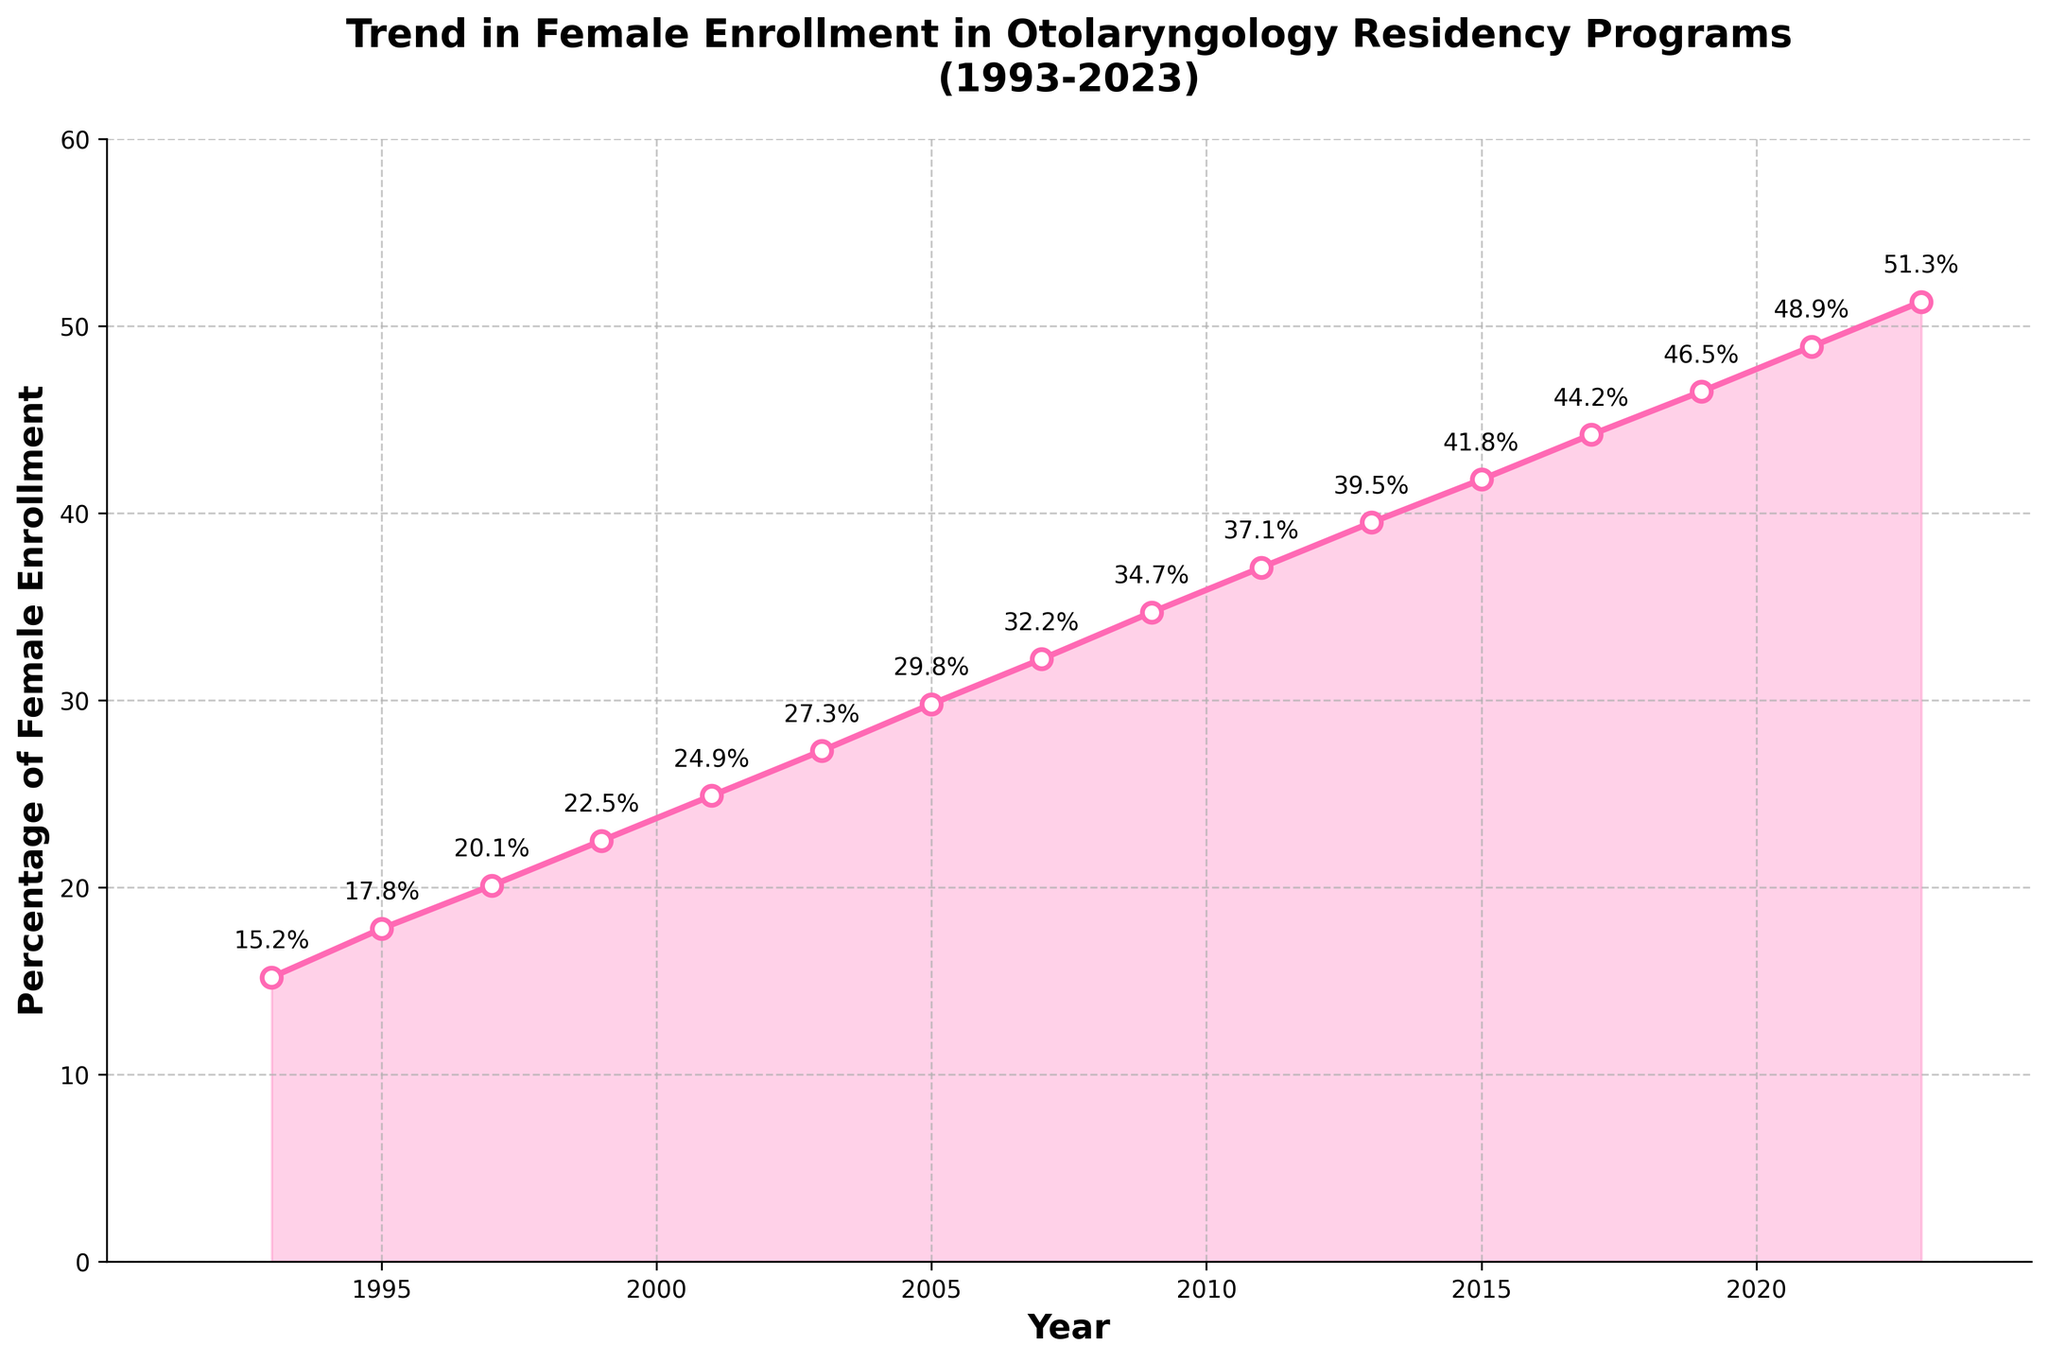What's the percentage of female enrollment in otolaryngology residency programs in 2005? To find the percentage of female enrollment in 2005, refer to the point marked for the year 2005. The value is labeled next to the point.
Answer: 29.8% In which year did female enrollment in otolaryngology residency programs surpass 40%? To determine the year when the percentage surpassed 40%, look for the first point after 2000 where the percentage marker is above 40%.
Answer: 2015 What is the difference in female enrollment percentage between 1993 and 2023? Find the percentages for 1993 and 2023 from the labeled points. Subtract the 1993 value (15.2%) from the 2023 value (51.3%).
Answer: 36.1% How many years did it take for the female enrollment percentage to double from the 1993 levels? To identify when the enrollment doubled from 1993 (15.2%), look for the year when the percentage reaches approximately 30.4%. Compare this to 1993 to find the number of years.
Answer: 12 years (2005) What is the average percentage of female enrollment from 1993 to 2023? Add the percentages for all the years and divide by the number of data points (16 years).
Answer: (15.2+17.8+20.1+22.5+24.9+27.3+29.8+32.2+34.7+37.1+39.5+41.8+44.2+46.5+48.9+51.3)/16 = 32.75 What was the trend between 2005 and 2015? Observe the points and the slope of the line between 2005 (29.8%) and 2015 (41.8%). The trend is upward.
Answer: Upward trend Interpret the overall trend in female enrollment over the 30-year period By observing the graph, it is evident that the overall trend shows a consistent and significant increase in female enrollment from 1993 to 2023.
Answer: Consistent increase Was the increase in female enrollment percentage steady throughout the period? Referring to the plot, examine any steep or flat portions by observing the slope of the line. While the increase is generally steady, some periods may show steeper increments (e.g., between 2007-2011) than others.
Answer: Mostly steady with some variations 